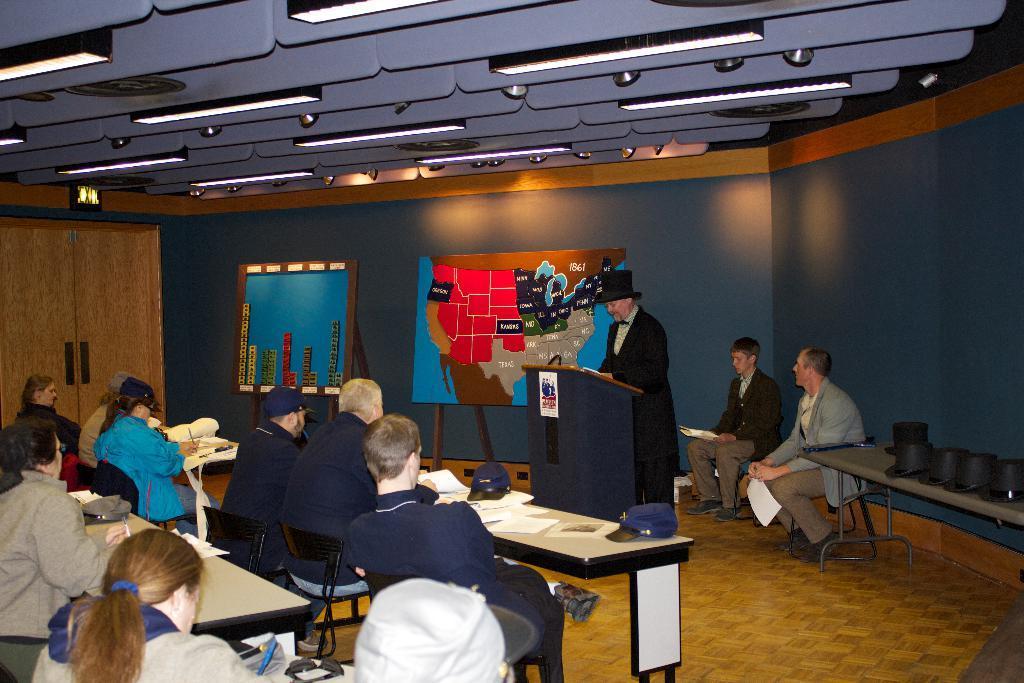In one or two sentences, can you explain what this image depicts? In this image I see few people sitting on the chairs and this man over here is standing in front of a podium, I can also see there are lot of tables and few things on it. In the background I see the boards, wall and the lights. 